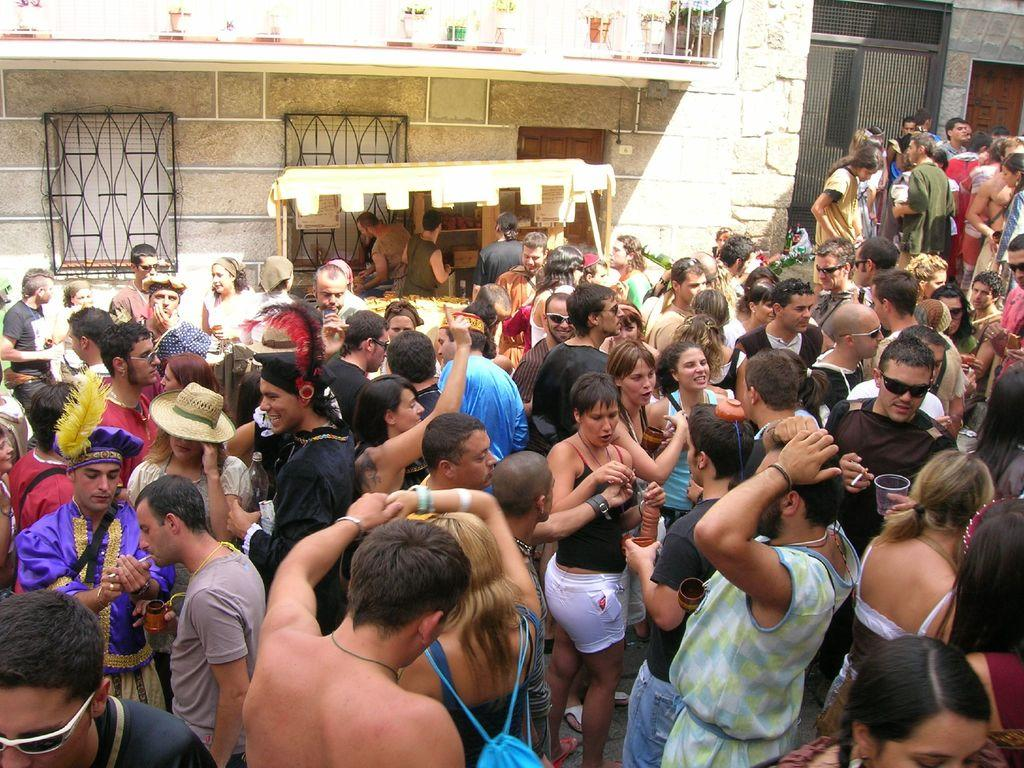What type of objects are present in the background of the image? In the background of the image, there are plants with pots and windows with grills. Can you describe the people in the background of the image? Yes, there are people standing in the background of the image. What is visible in the bottom portion of the image? In the bottom portion of the image, there are people standing. What can be observed about some of the people standing in the bottom portion? Among the people standing in the bottom portion, some are wearing goggles. What type of hose is being used by the people standing in the image? There is no hose visible in the image. How many steps are required for the people to reach the top of the structure in the image? There is no structure present in the image that requires steps to reach the top. 